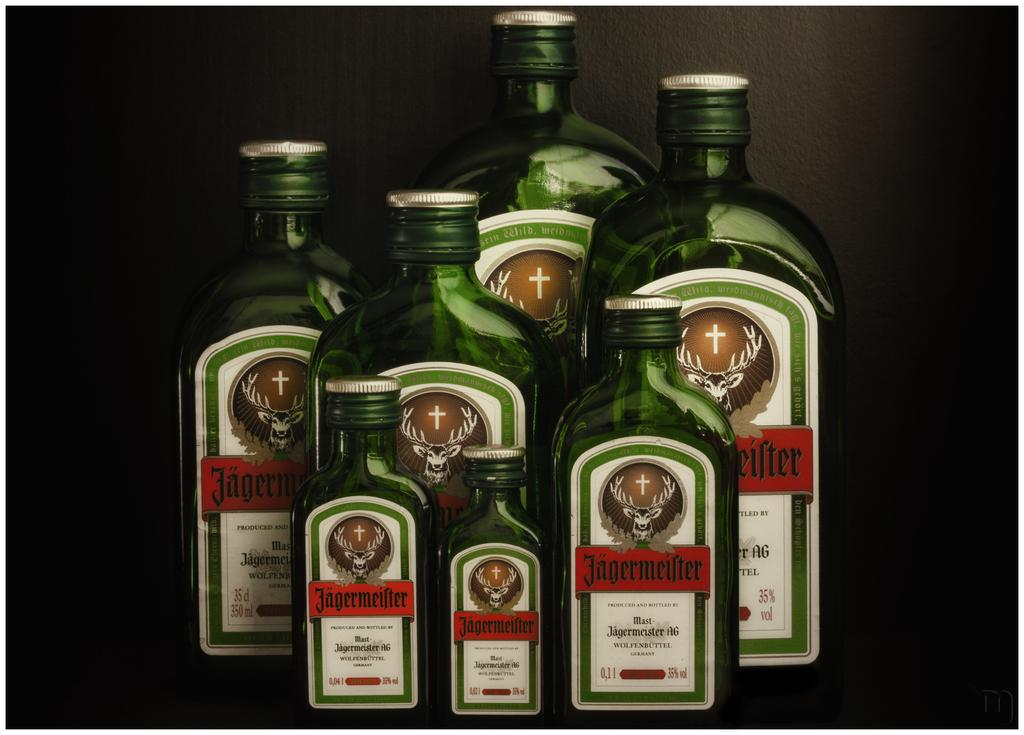How many green bottles are in the image? There are seven green color bottles in the image. What can be observed about the shapes of the bottles? The bottles have different shapes. Are the bottles open or closed? The bottles are sealed. What is visible in the background of the image? There is a black color wall in the background of the image. What advice is given by the bottles in the image? The bottles in the image do not give any advice, as they are inanimate objects. 